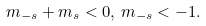<formula> <loc_0><loc_0><loc_500><loc_500>m _ { - s } + m _ { s } < 0 , \, m _ { - s } < - 1 .</formula> 